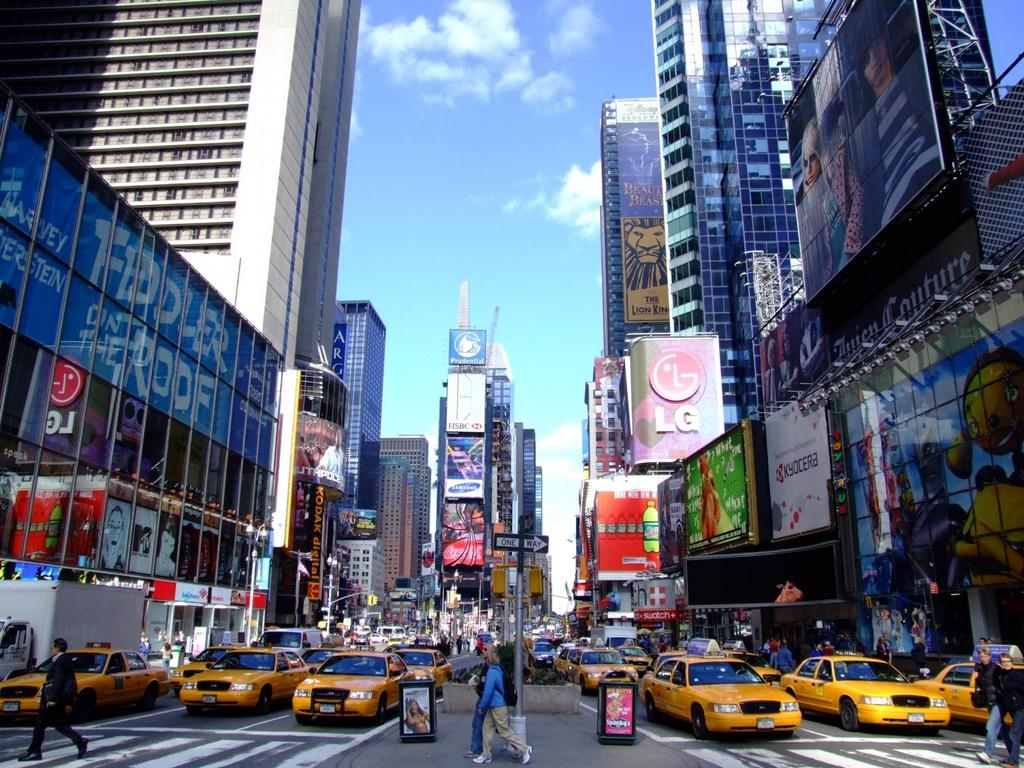<image>
Render a clear and concise summary of the photo. a city street with LG above some of the buildings 